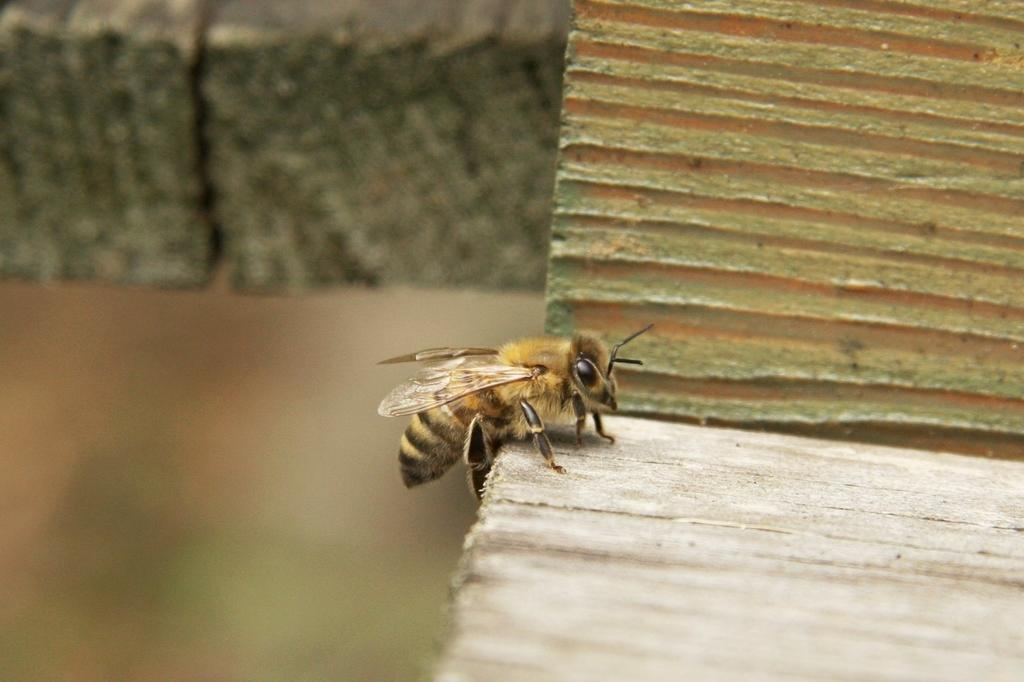What type of insect is in the image? There is a honey bee in the image. What surface is the honey bee on? The honey bee is on a wood surface. Can you describe the background of the image? The background of the image is blurred. How many boats are visible in the image? There are no boats present in the image; it features a honey bee on a wood surface with a blurred background. 